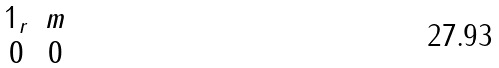Convert formula to latex. <formula><loc_0><loc_0><loc_500><loc_500>\begin{matrix} 1 _ { r } & m \\ 0 & 0 \end{matrix}</formula> 